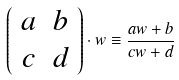<formula> <loc_0><loc_0><loc_500><loc_500>\left ( \begin{array} { c c } a & b \\ c & d \\ \end{array} \right ) \cdot w \equiv \frac { a w + b } { c w + d }</formula> 